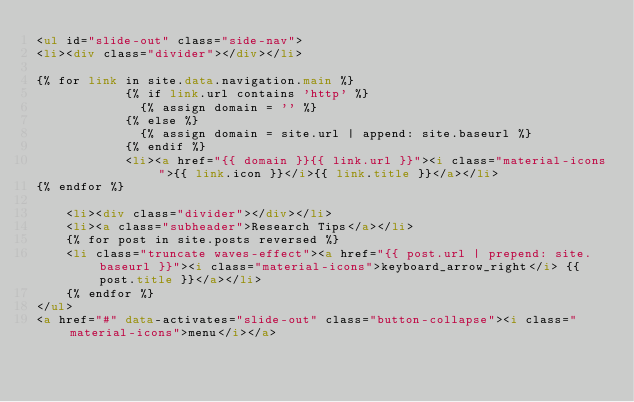Convert code to text. <code><loc_0><loc_0><loc_500><loc_500><_HTML_><ul id="slide-out" class="side-nav">
<li><div class="divider"></div></li>
    
{% for link in site.data.navigation.main %}
            {% if link.url contains 'http' %}
              {% assign domain = '' %}
            {% else %}
              {% assign domain = site.url | append: site.baseurl %}
            {% endif %}
            <li><a href="{{ domain }}{{ link.url }}"><i class="material-icons">{{ link.icon }}</i>{{ link.title }}</a></li>
{% endfor %}
    
    <li><div class="divider"></div></li>
    <li><a class="subheader">Research Tips</a></li>    
    {% for post in site.posts reversed %}
    <li class="truncate waves-effect"><a href="{{ post.url | prepend: site.baseurl }}"><i class="material-icons">keyboard_arrow_right</i> {{ post.title }}</a></li>
    {% endfor %}
</ul>
<a href="#" data-activates="slide-out" class="button-collapse"><i class="material-icons">menu</i></a> </code> 